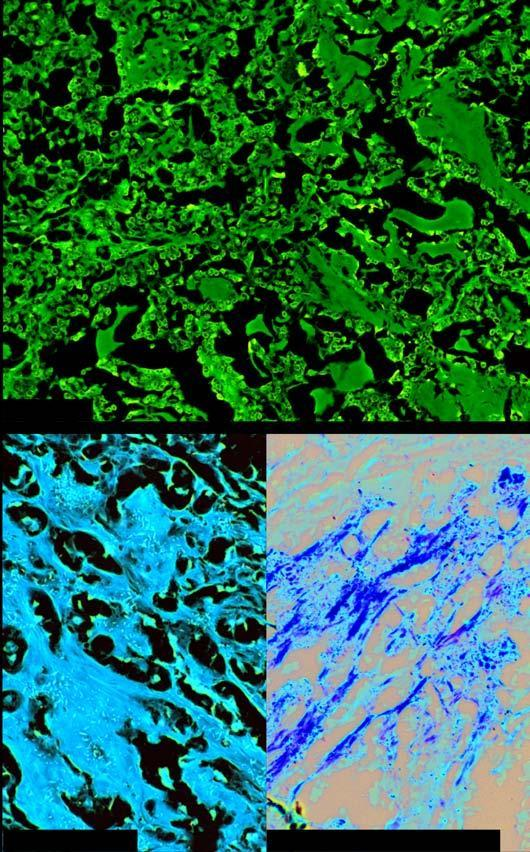does amyloid show congophilia which depicts apple-green birefringence under polarising microscopy?
Answer the question using a single word or phrase. Yes 